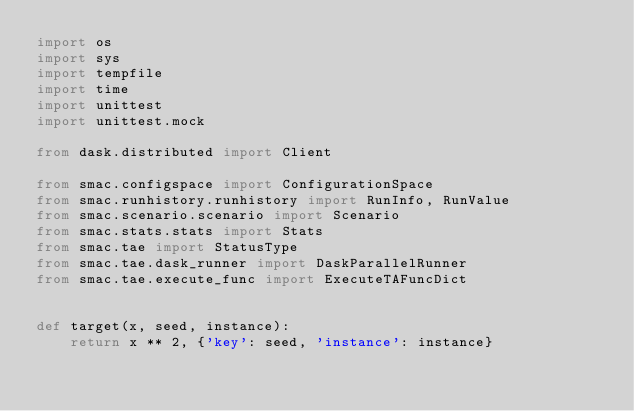Convert code to text. <code><loc_0><loc_0><loc_500><loc_500><_Python_>import os
import sys
import tempfile
import time
import unittest
import unittest.mock

from dask.distributed import Client

from smac.configspace import ConfigurationSpace
from smac.runhistory.runhistory import RunInfo, RunValue
from smac.scenario.scenario import Scenario
from smac.stats.stats import Stats
from smac.tae import StatusType
from smac.tae.dask_runner import DaskParallelRunner
from smac.tae.execute_func import ExecuteTAFuncDict


def target(x, seed, instance):
    return x ** 2, {'key': seed, 'instance': instance}

</code> 